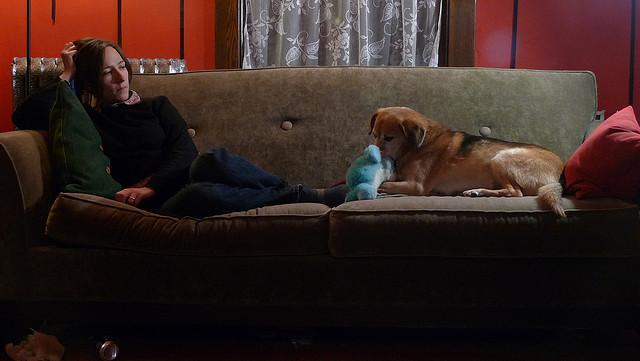How many dogs are there?
Give a very brief answer. 1. How many couches are visible?
Give a very brief answer. 1. 